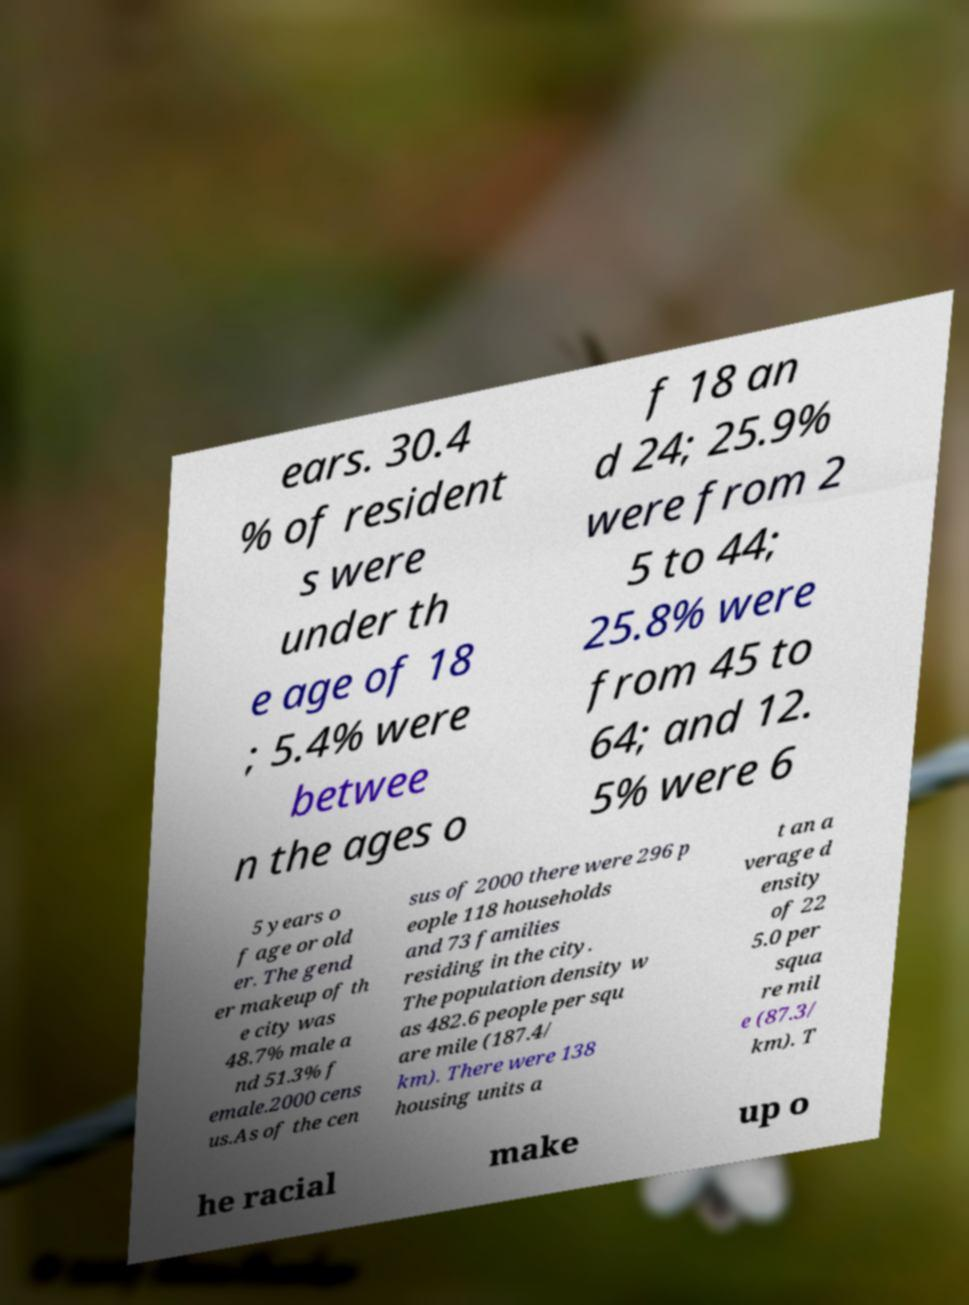What messages or text are displayed in this image? I need them in a readable, typed format. ears. 30.4 % of resident s were under th e age of 18 ; 5.4% were betwee n the ages o f 18 an d 24; 25.9% were from 2 5 to 44; 25.8% were from 45 to 64; and 12. 5% were 6 5 years o f age or old er. The gend er makeup of th e city was 48.7% male a nd 51.3% f emale.2000 cens us.As of the cen sus of 2000 there were 296 p eople 118 households and 73 families residing in the city. The population density w as 482.6 people per squ are mile (187.4/ km). There were 138 housing units a t an a verage d ensity of 22 5.0 per squa re mil e (87.3/ km). T he racial make up o 